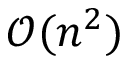Convert formula to latex. <formula><loc_0><loc_0><loc_500><loc_500>\mathcal { O } ( n ^ { 2 } )</formula> 